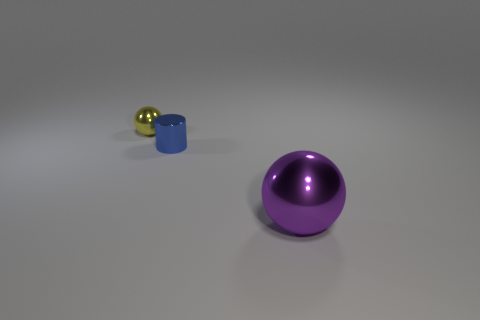There is a blue thing that is the same size as the yellow shiny ball; what shape is it?
Provide a succinct answer. Cylinder. Are there any yellow shiny objects that have the same shape as the blue thing?
Provide a succinct answer. No. There is a tiny thing that is to the right of the tiny sphere; is it the same shape as the thing that is to the right of the tiny blue metal cylinder?
Offer a terse response. No. What is the material of the blue object that is the same size as the yellow object?
Keep it short and to the point. Metal. What number of other things are the same material as the tiny yellow object?
Your answer should be very brief. 2. There is a large purple object in front of the sphere that is left of the purple thing; what is its shape?
Ensure brevity in your answer.  Sphere. What number of objects are either big things or metallic things that are left of the large thing?
Provide a short and direct response. 3. How many other objects are there of the same color as the tiny metal ball?
Make the answer very short. 0. What number of yellow things are small objects or tiny cylinders?
Ensure brevity in your answer.  1. Are there any tiny things on the left side of the small shiny object on the right side of the ball that is behind the purple sphere?
Ensure brevity in your answer.  Yes. 